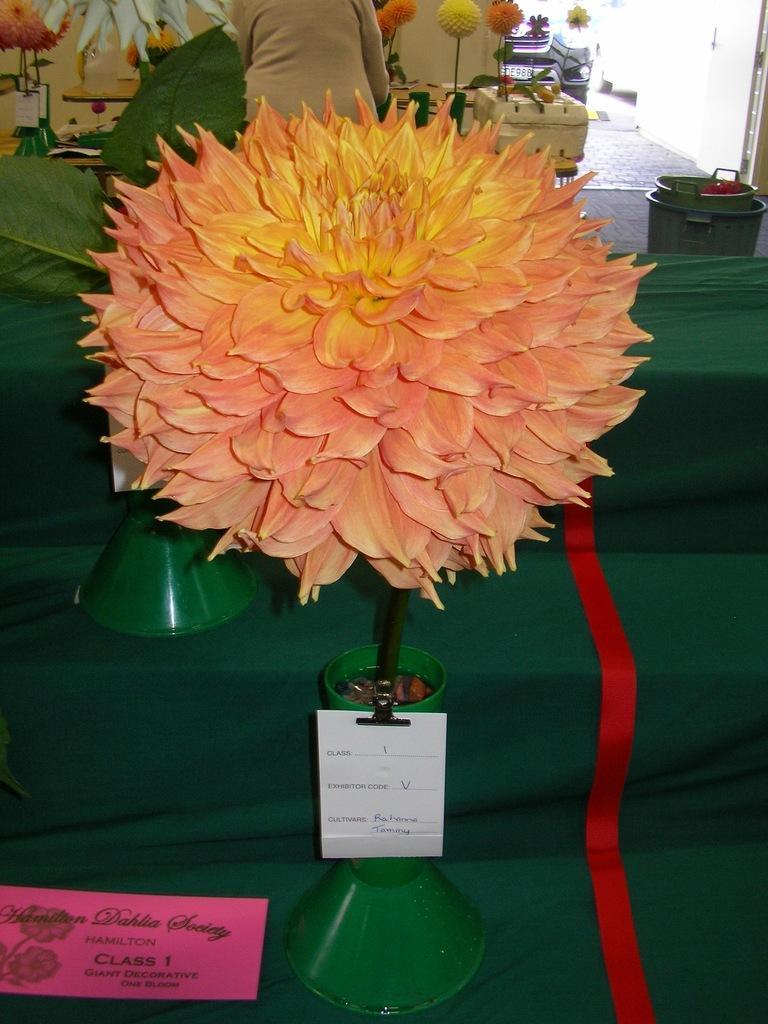In one or two sentences, can you explain what this image depicts? In the foreground I can see a houseplant and a card on the steps. In the background I can see tubs, flower pots and a person. This image is taken in a shop. 